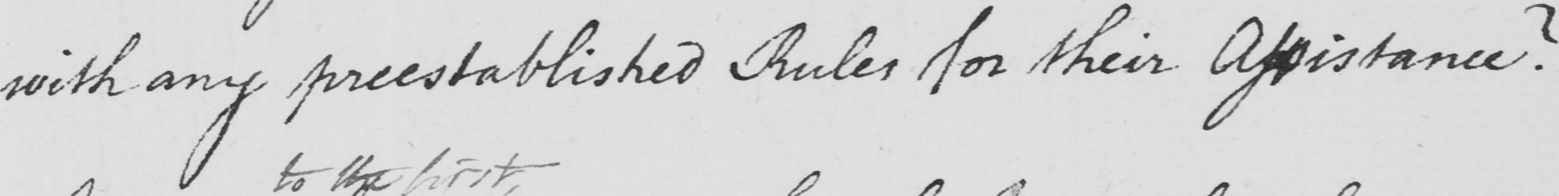Please provide the text content of this handwritten line. with any preestablished Rules for their Assistance ? 